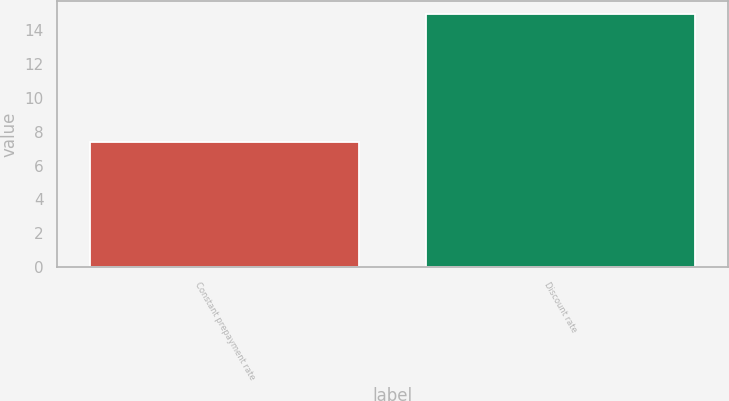<chart> <loc_0><loc_0><loc_500><loc_500><bar_chart><fcel>Constant prepayment rate<fcel>Discount rate<nl><fcel>7.4<fcel>15<nl></chart> 